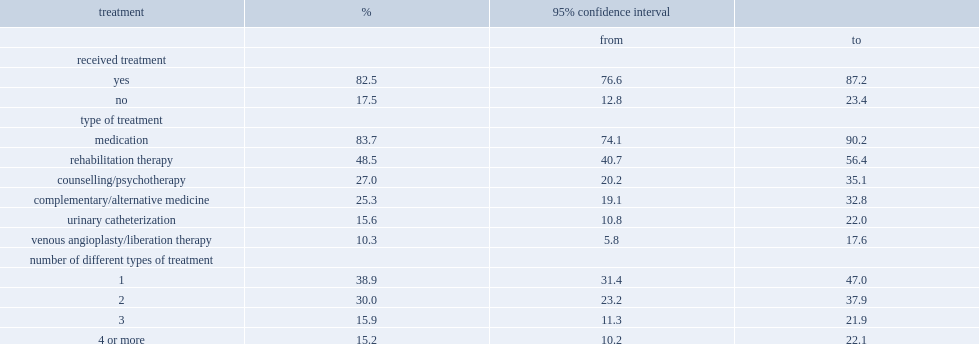What is the percentage of canadians aged 15 or older with ms reported using one or more treatments? 82.5. What is the percentage of people who receive treatment chose to take medications? 83.7. What is the percentage of people who receive treatment chose to use counselling? 27.0. What is the percentage of people who receive treatment chose to use complementary medicine? 25.3. What is the percentage of people who received treatment reported one type treatment strategy? 38.9. What is the percentage of people who received treatment reported multiple treatment strategies? 61.1. 